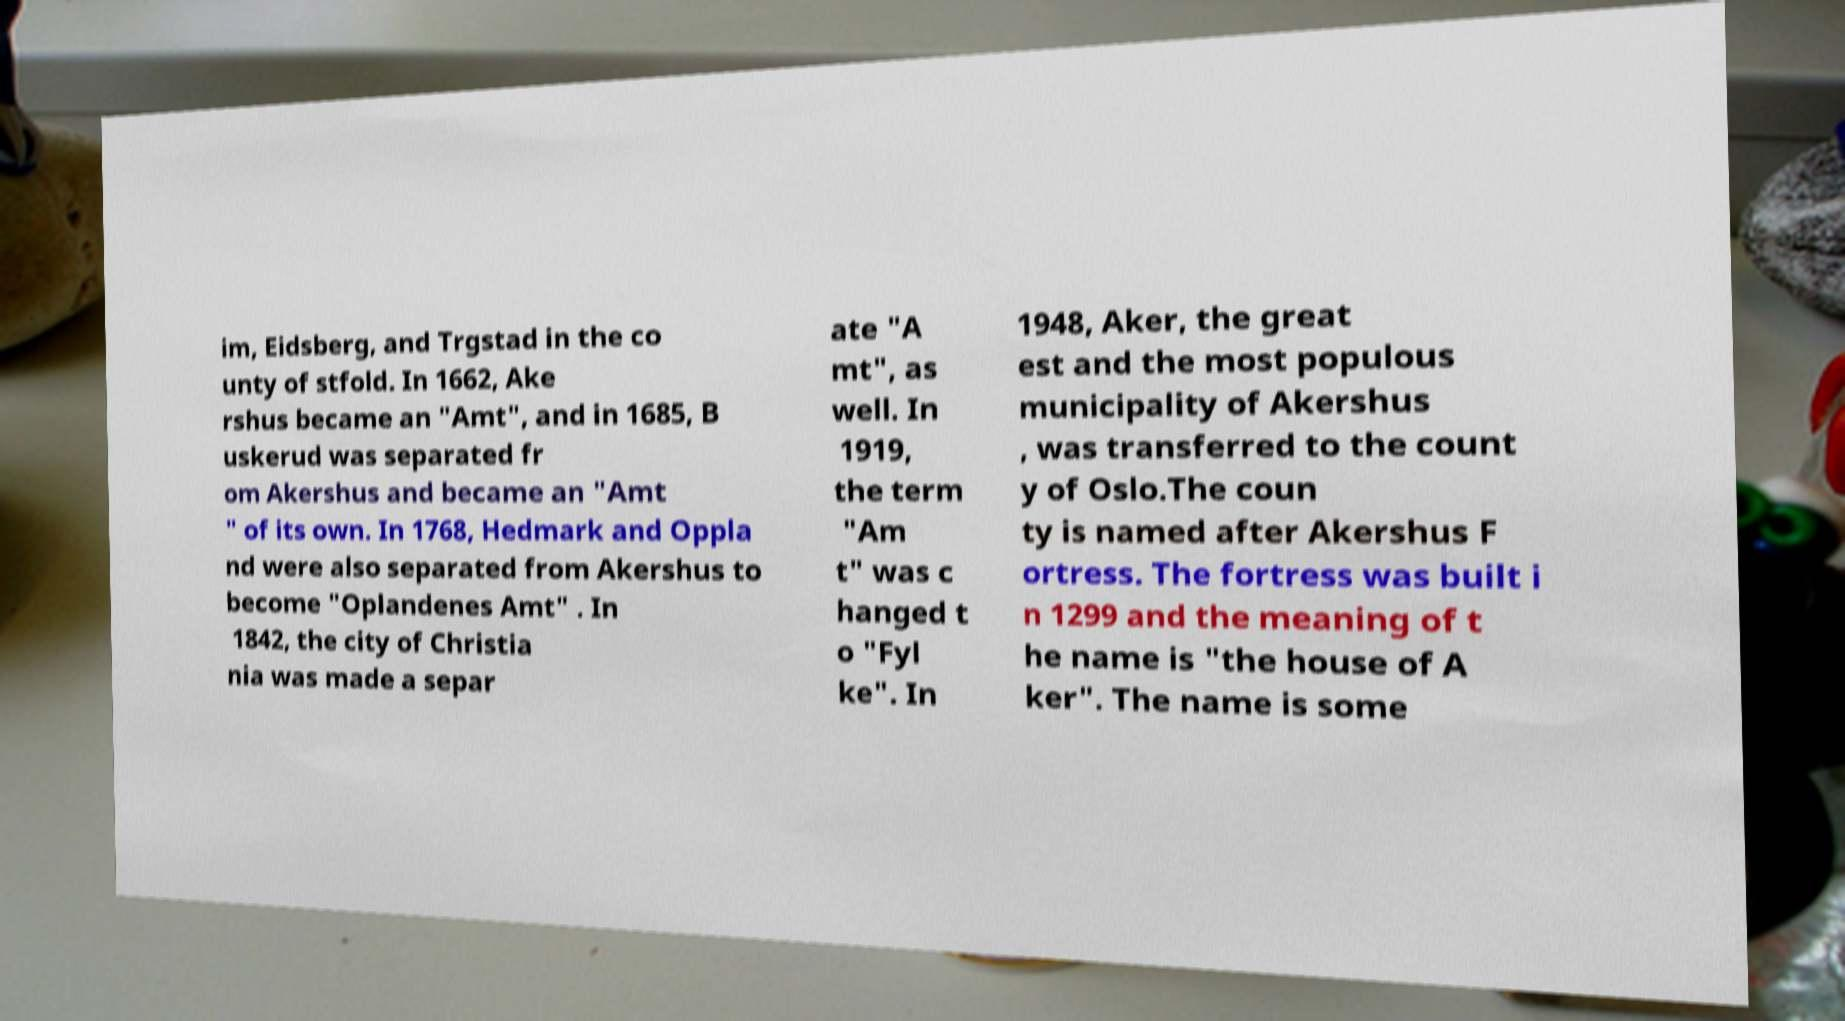For documentation purposes, I need the text within this image transcribed. Could you provide that? im, Eidsberg, and Trgstad in the co unty of stfold. In 1662, Ake rshus became an "Amt", and in 1685, B uskerud was separated fr om Akershus and became an "Amt " of its own. In 1768, Hedmark and Oppla nd were also separated from Akershus to become "Oplandenes Amt" . In 1842, the city of Christia nia was made a separ ate "A mt", as well. In 1919, the term "Am t" was c hanged t o "Fyl ke". In 1948, Aker, the great est and the most populous municipality of Akershus , was transferred to the count y of Oslo.The coun ty is named after Akershus F ortress. The fortress was built i n 1299 and the meaning of t he name is "the house of A ker". The name is some 